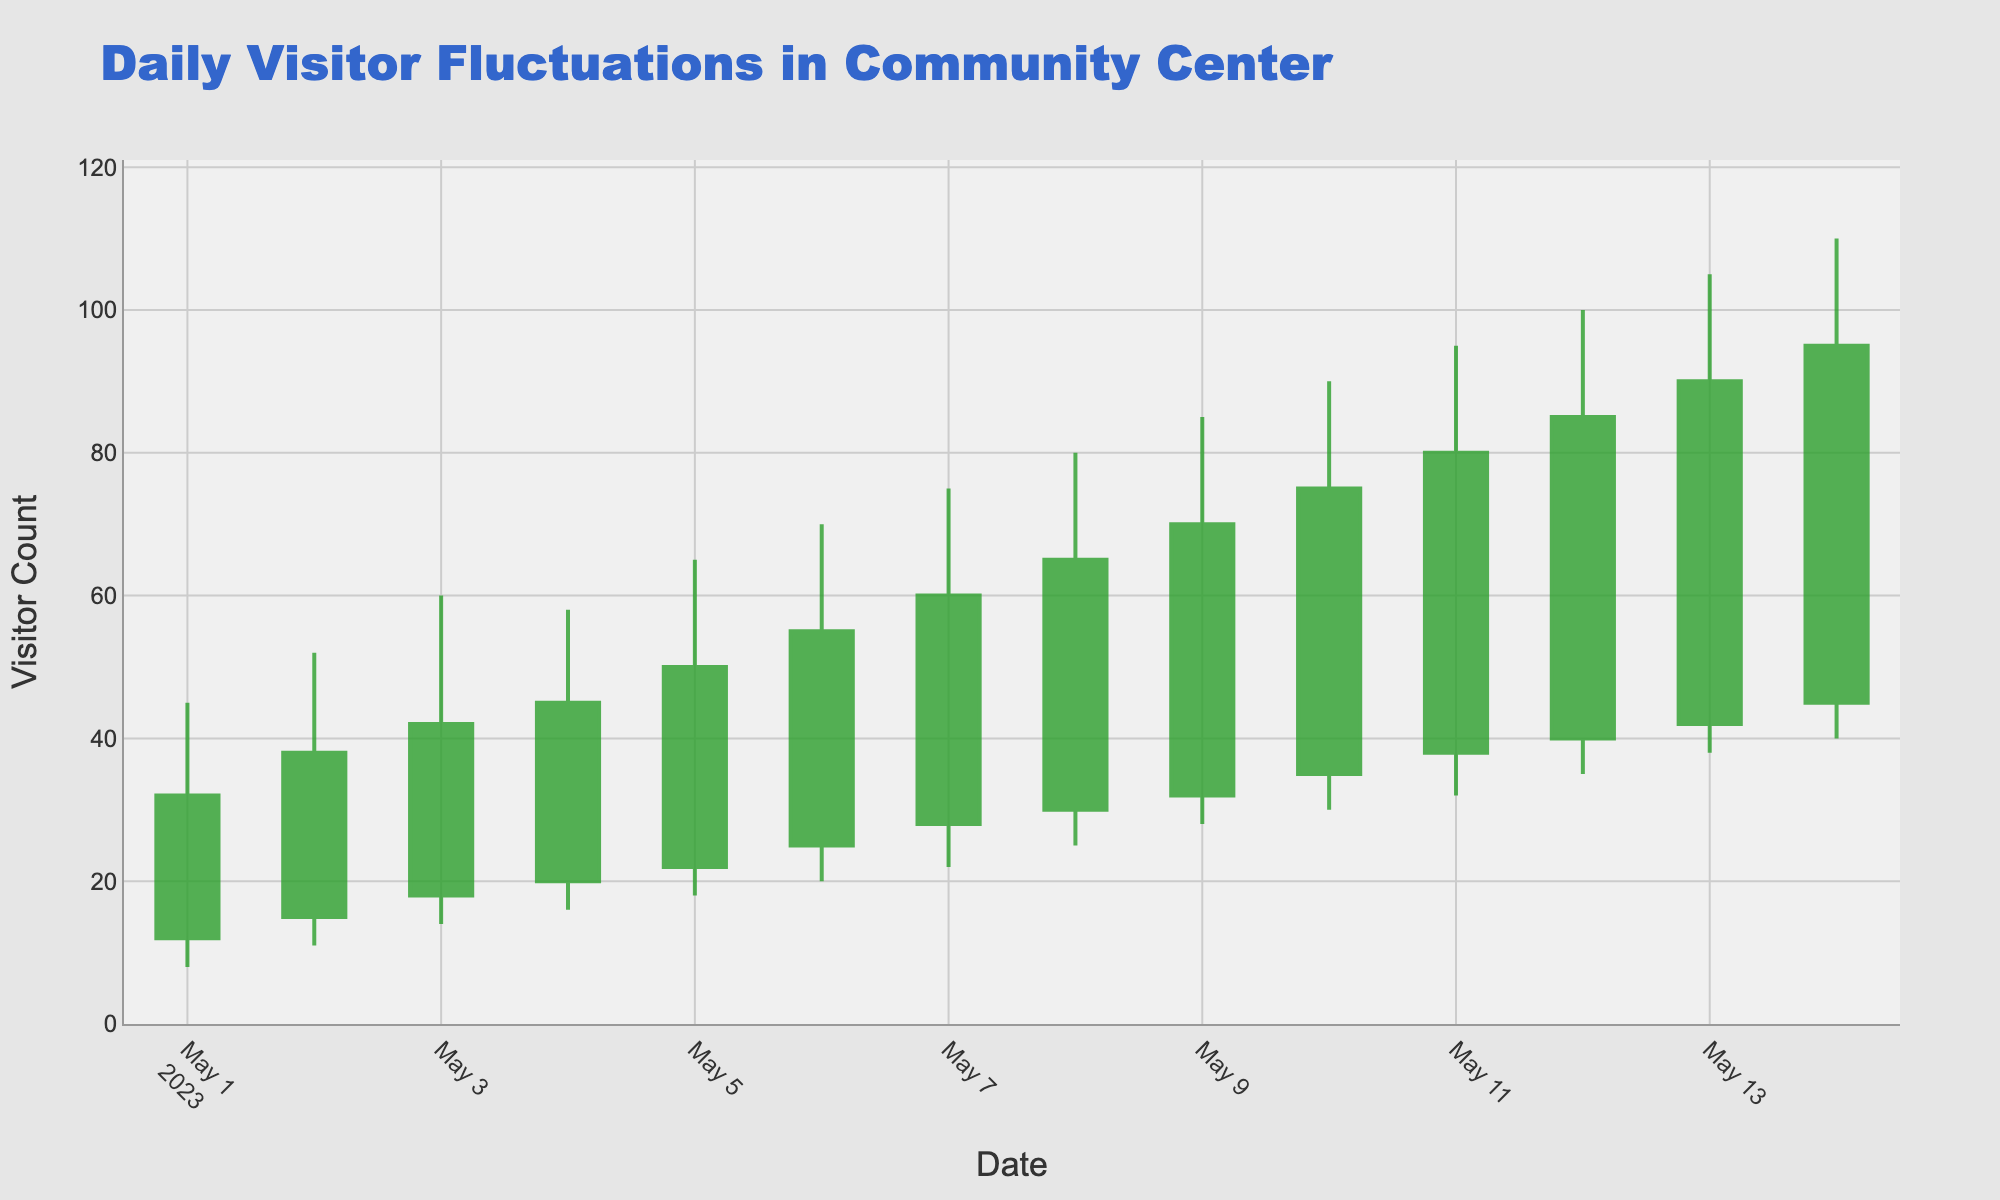What is the title of the chart? The title is displayed at the top of the chart and describes the content of the figure.
Answer: Daily Visitor Fluctuations in Community Center How many days are covered in the chart? The X-axis shows the date range from 2023-05-01 to 2023-05-14, so we count the number of days in this range.
Answer: 14 Which day had the highest maximum visitor count? The 'High' values for each day need to be compared to find the highest one, which is 110 on 2023-05-14.
Answer: 2023-05-14 What is the increase in the closing visitor count from the first day to the last day? Find the 'Close' value for the first day (32 on 2023-05-01) and the last day (95 on 2023-05-14) and calculate the difference (95 - 32).
Answer: 63 What's the average 'Low' visitor count over the entire period? Sum the 'Low' values from each day (8+11+14+16+18+20+22+25+28+30+32+35+38+40) and divide by the number of days (14).
Answer: 24.36 How many days had a higher 'Close' visitor count than their 'Open' value? For each day, check if the 'Close' value is greater than the 'Open' value and count those days.
Answer: 14 Which day had the smallest range of visitor counts (High - Low)? Calculate the difference between 'High' and 'Low' values for each day and find the day with the smallest difference. The day with the smallest range is 2023-05-10, with a difference of 60 (90 - 30).
Answer: 2023-05-10 What was the visitor trend from 2023-05-01 to 2023-05-14: increasing, decreasing, or fluctuating? By examining the general direction of the 'Close' values from start to end, we see a steady increase from 32 to 95.
Answer: Increasing Which color represents increasing visitor counts in the candlestick chart? The chart uses a green color for increasing candles, which makes it easy to identify days with a higher 'Close' than 'Open.'
Answer: Green What is the highest number of visitors recorded at any point during the period? By identifying the highest 'High' value in the data, which is 110 on 2023-05-14, we determine the peak visitor count.
Answer: 110 